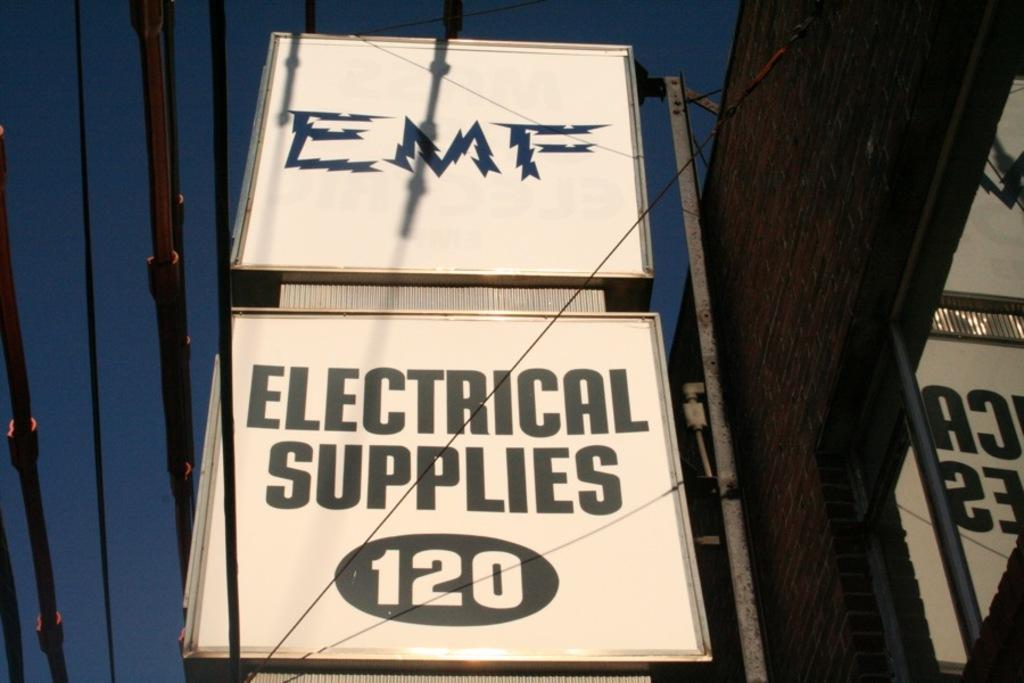<image>
Present a compact description of the photo's key features. EMF electrical supplies has a white and black sign 